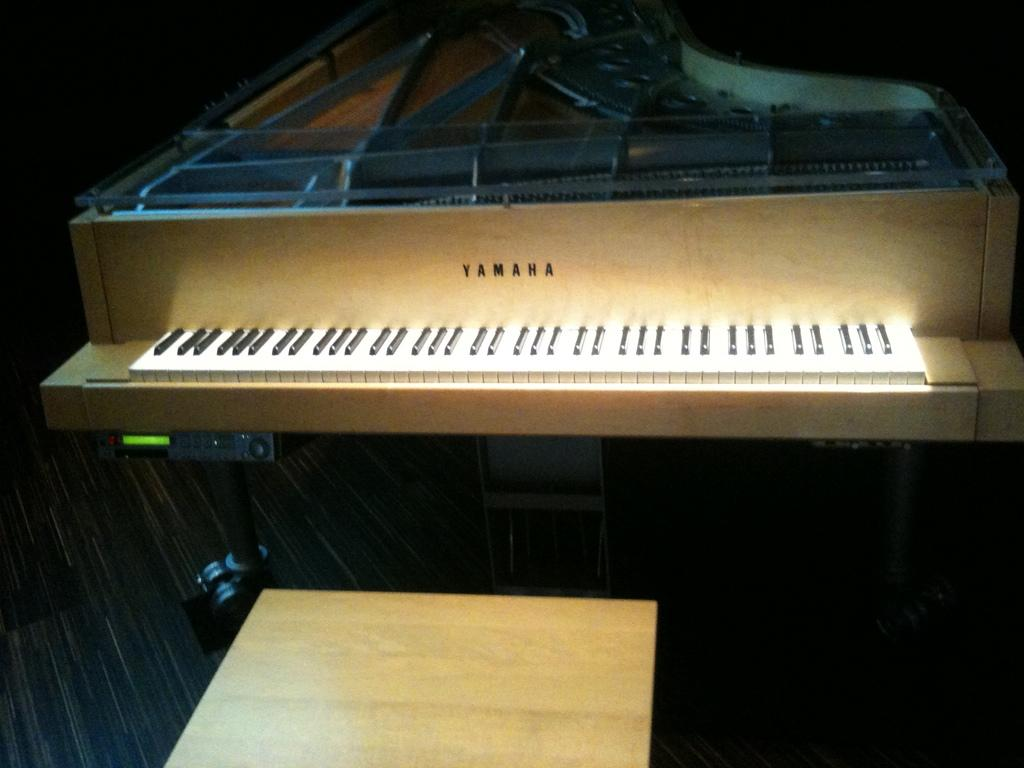What musical instrument is present in the image? There is a piano in the image. What part of the piano is used for playing music? The piano has a keyboard. What brand is the piano made by? The piano is made by Yamaha, as indicated by the writing on the piano. What color is the crayon used to write the brand name on the piano? There is no crayon present in the image; the brand name is written on the piano using a different method, such as paint or engraving. 